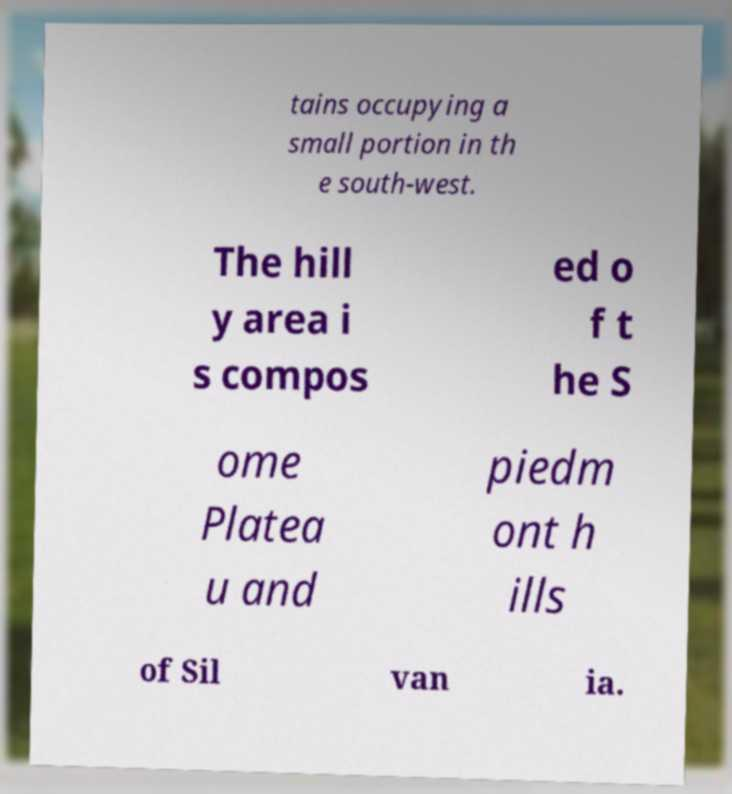What messages or text are displayed in this image? I need them in a readable, typed format. tains occupying a small portion in th e south-west. The hill y area i s compos ed o f t he S ome Platea u and piedm ont h ills of Sil van ia. 